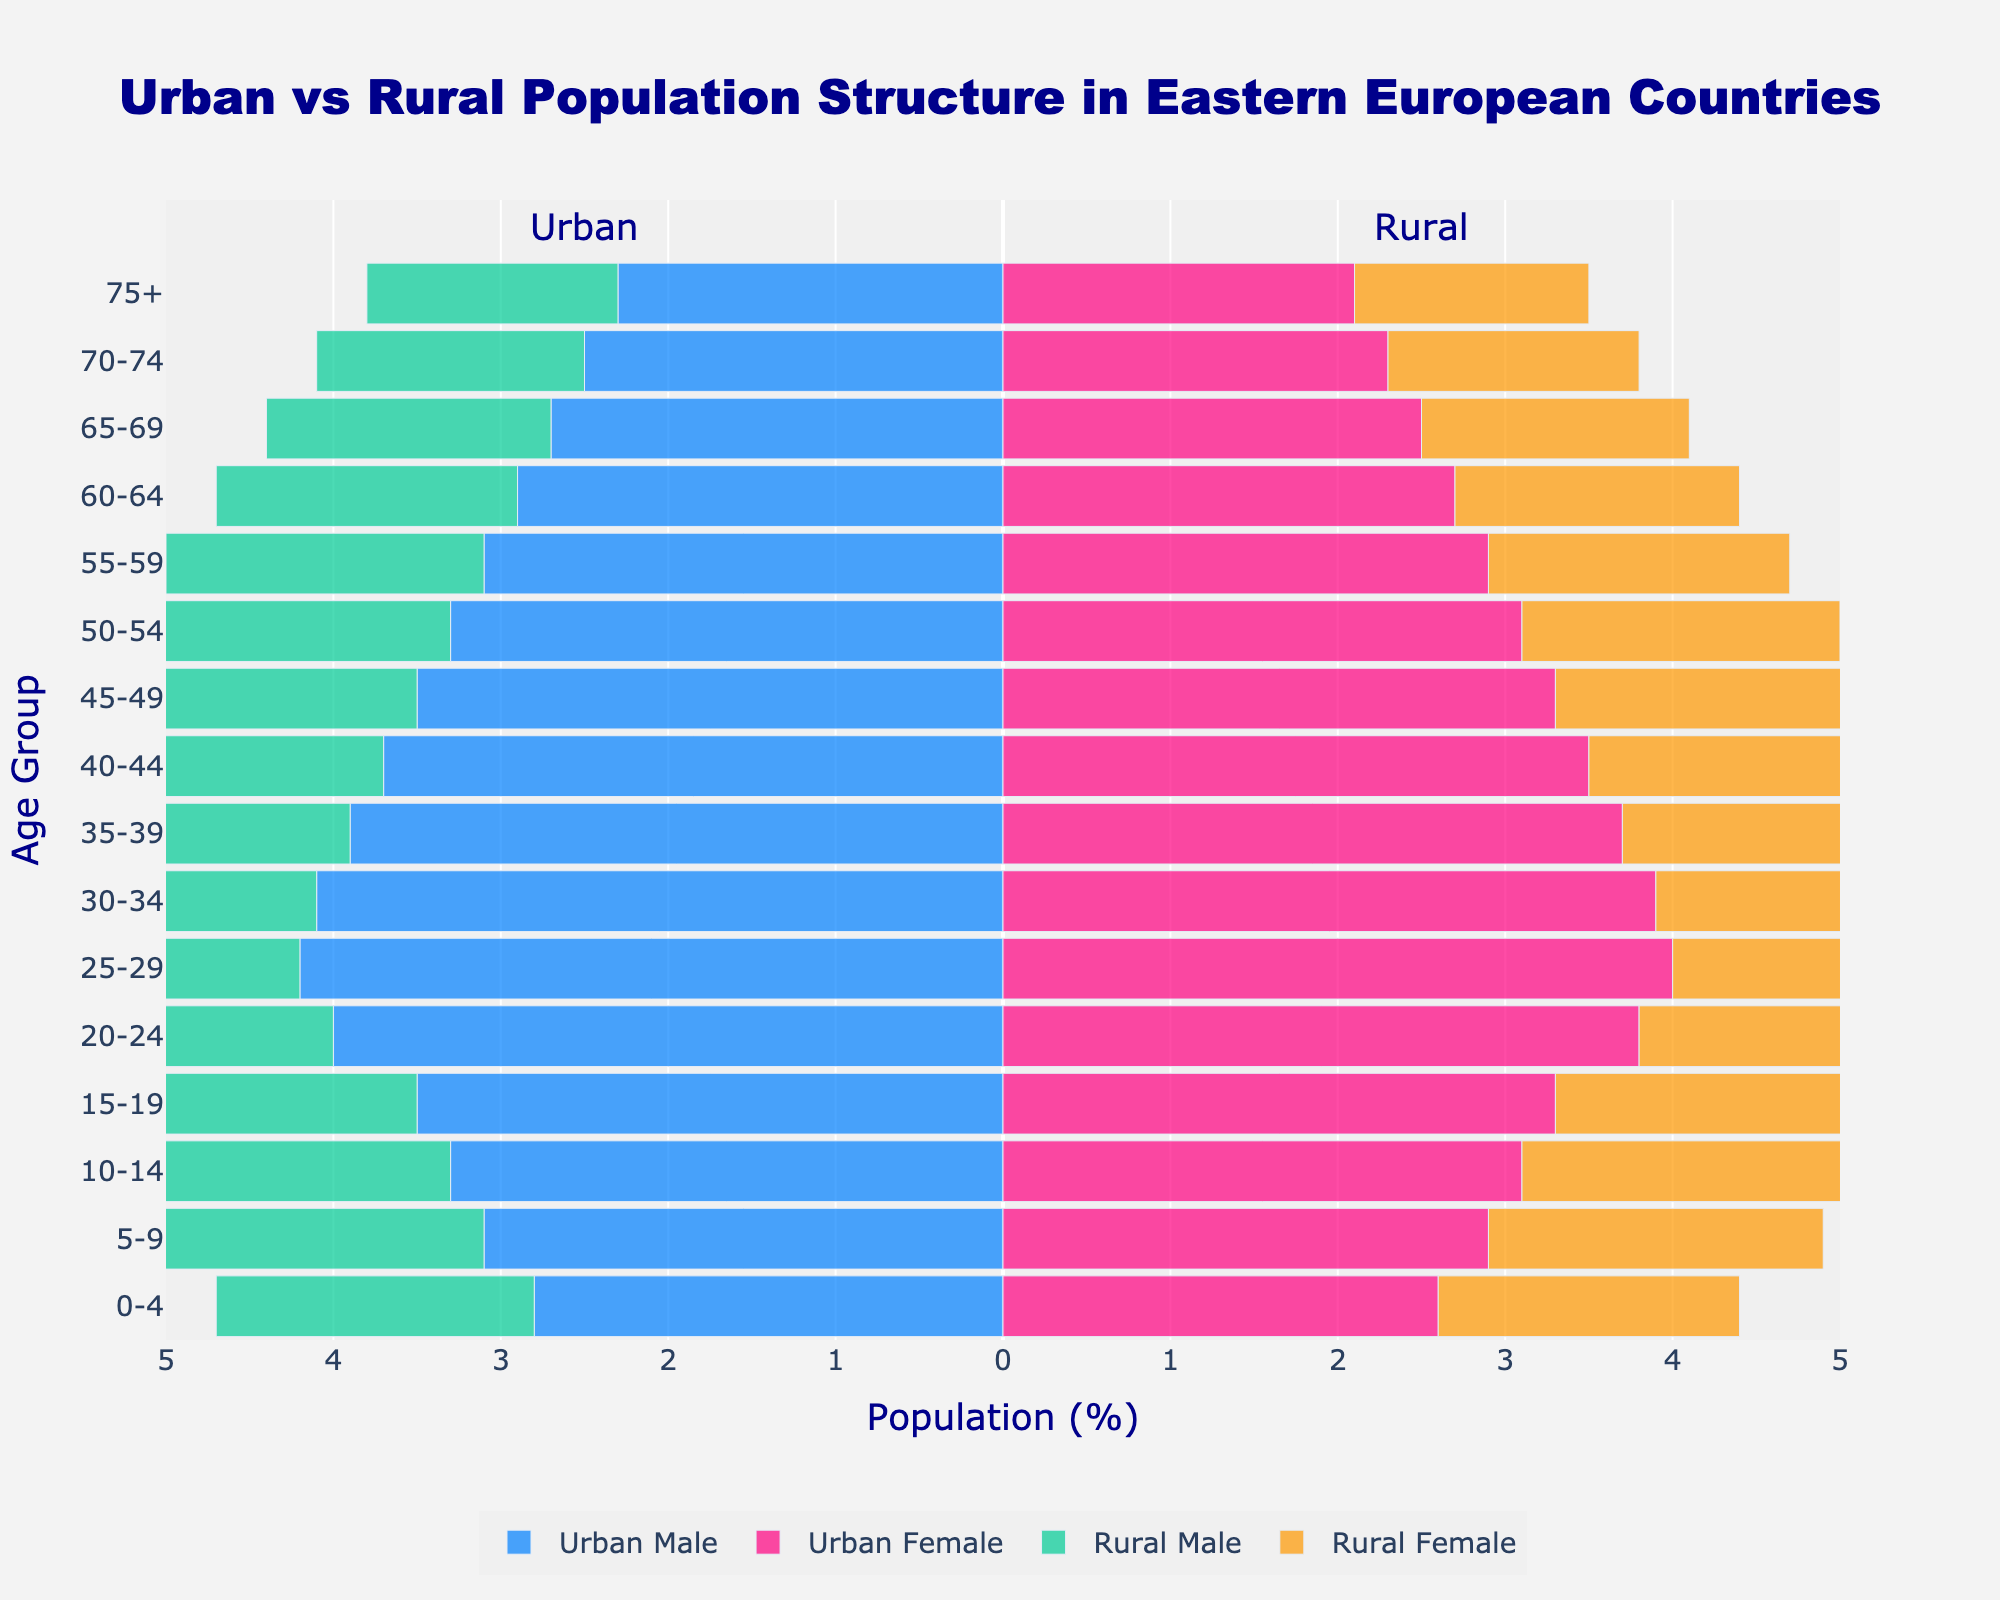What is the overall title of the figure? The title is prominently displayed at the top of the figure and reads "Urban vs Rural Population Structure in Eastern European Countries." This title summarizes the focus of the population pyramid.
Answer: Urban vs Rural Population Structure in Eastern European Countries What do the colors in the figure represent? The colors differentiate between urban and rural populations as well as between genders. Blue (Urban Male), Pink (Urban Female), Green (Rural Male), and Orange (Rural Female). These color codes help in visual segregation of the data.
Answer: Blue, Pink, Green, Orange What age group has the highest percentage of urban males? Look at the bars representing urban males (blue) on the left side of the figure. The longest bar in this category corresponds to the 25-29 age group, which has the highest percentage.
Answer: 25-29 Which age group has the smallest difference between rural male and rural female populations? Compare the lengths of the green and orange bars for each age group. The differences are smallest where the bars have similar lengths. The 0-4 age group has the smallest visual difference.
Answer: 0-4 How does the population percentage of urban females in the 75+ age group compare to urban males in the same group? Compare the lengths of the pink and blue bars in the 75+ category. The urban female (pink) bar is longer than the urban male (blue) bar, indicating a higher percentage.
Answer: Urban females have a higher percentage In the 20-24 age group, how does the population percentage of urban males compare to rural males? Check the lengths of the blue bar for urban males and the green bar for rural males. The urban male percentage is longer, signifying a higher percentage compared to rural males.
Answer: Urban males have a higher percentage What's the combined percentage of urban and rural females in the 10-14 age group? Add the percentages of urban females (3.1%) and rural females (2.2%) in the 10-14 age group. The sum is 3.1 + 2.2 = 5.3.
Answer: 5.3 Which gender has a greater percentage in the rural population for the age group 65-69? Compare the lengths of the green (rural male) and orange (rural female) bars in the 65-69 age group. The orange bar is longer, indicating that rural females have a greater percentage.
Answer: Rural females 